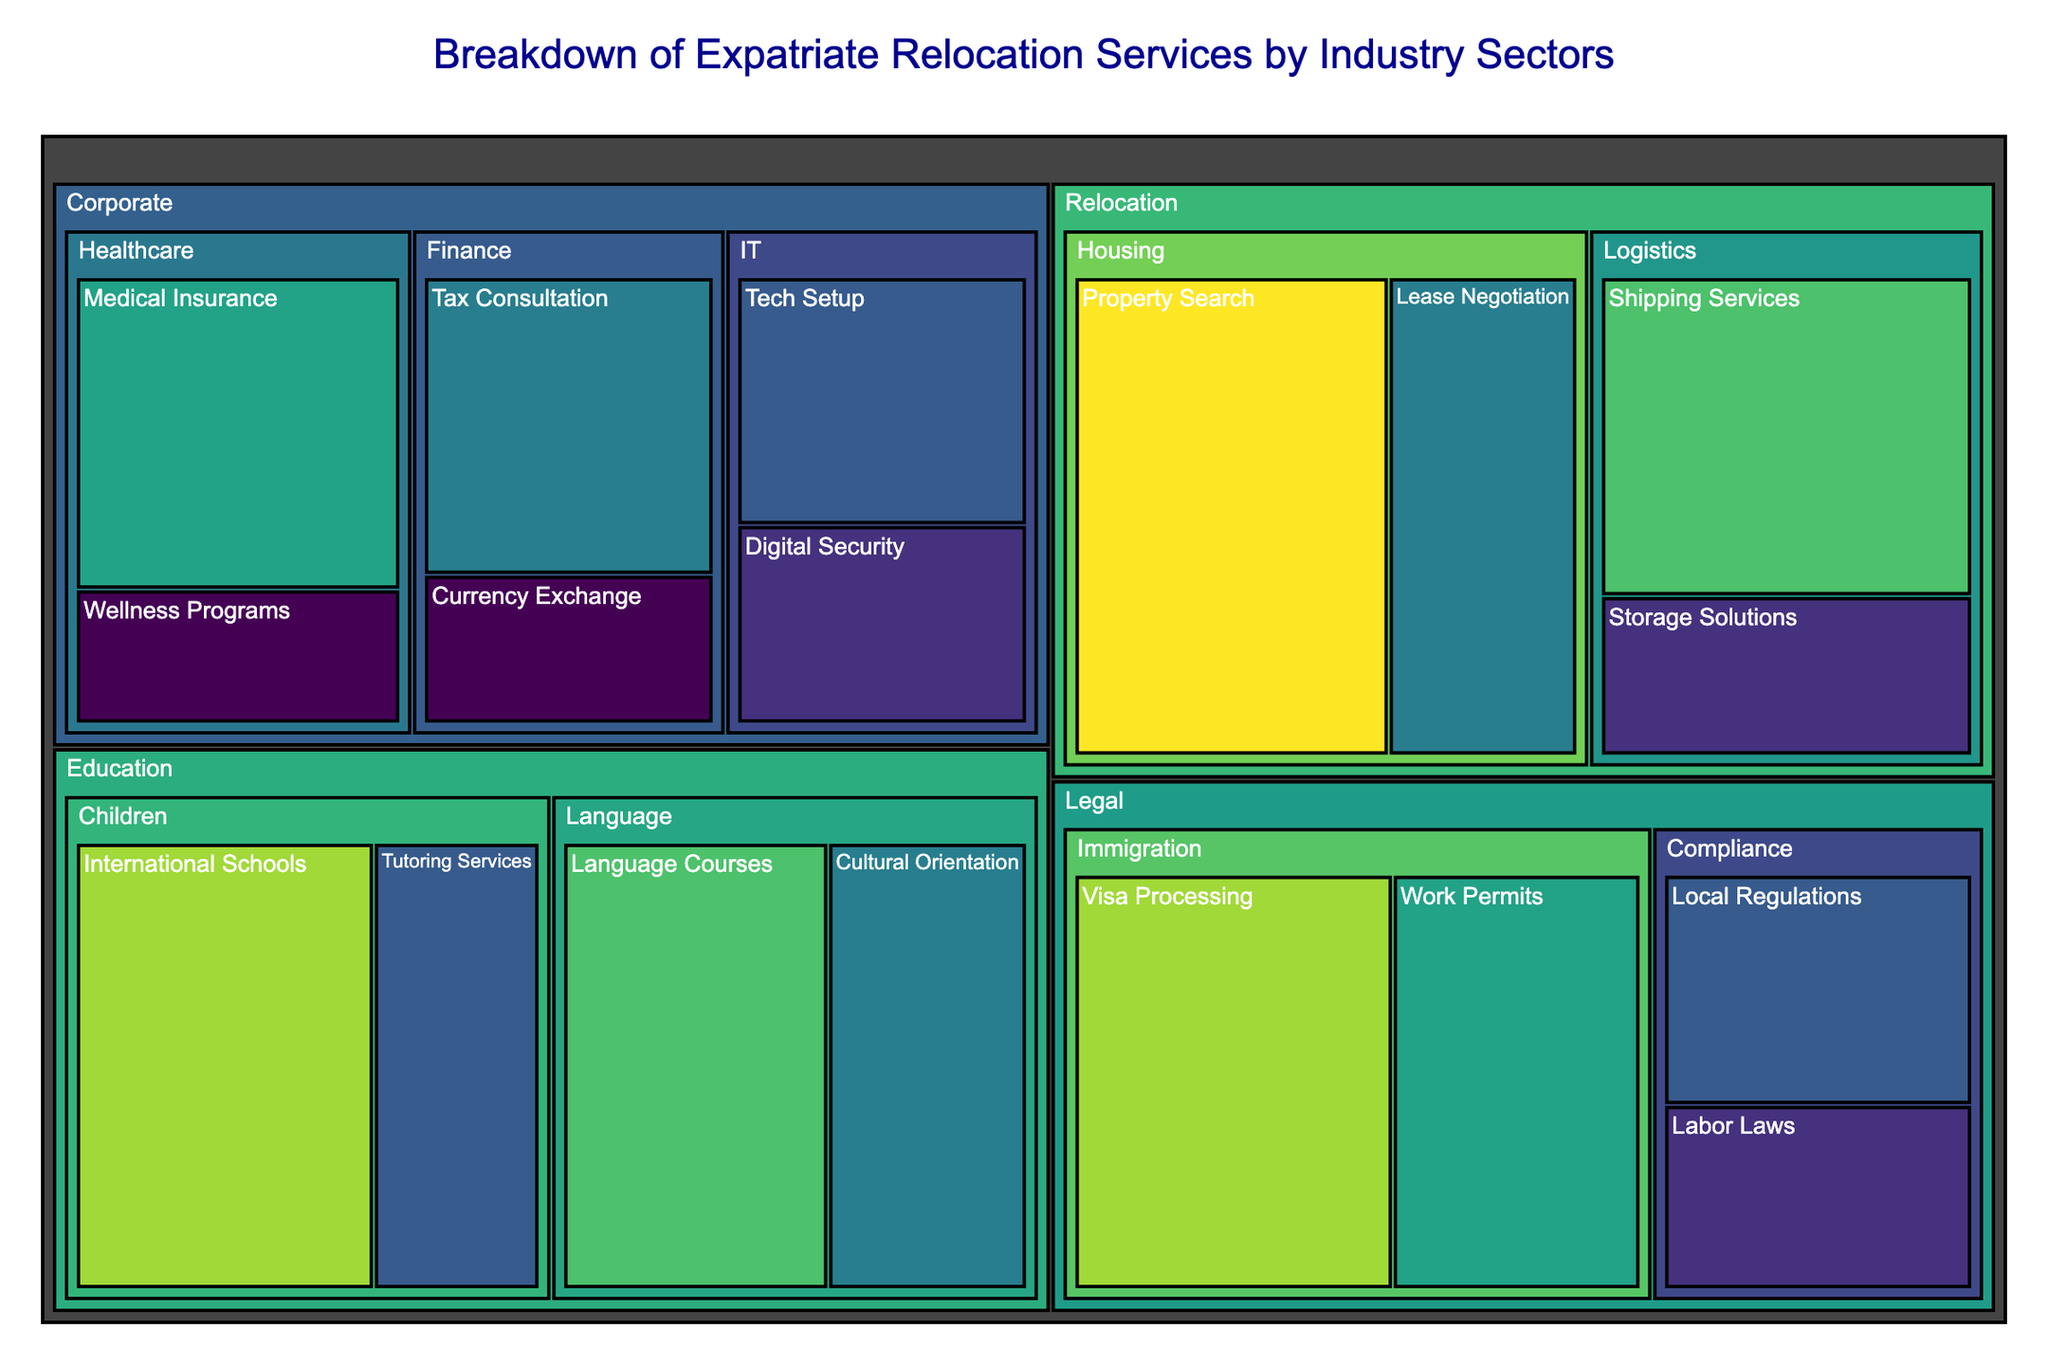Which industry sector has the highest value in its services? By looking at the treemap, identify the blocks with the largest areas because the area corresponds to the value of the services provided. The sector with the largest block will have the highest total value. In this case, it is the **Housing** sector under **Relocation** with values of 50 and 30, making a total of 80.
Answer: Housing What is the total value of services in the Corporate IT sector? Locate the IT sector under the Corporate industry in the treemap. Sum the values of all services within this sector, which are 25 and 20. Therefore, the total is 25 + 20.
Answer: 45 What service has the largest value in the Legal industry? Within the Legal industry on the treemap, identify the service with the largest block (area). This represents the service with the highest value. In this case, it is the Visa Processing service with a value of 45.
Answer: Visa Processing Compare the values of Property Search and Language Courses services. Which one is larger? Locate both Property Search under Relocation Housing and Language Courses under Education Language in the treemap. Compare their values. Property Search has a value of 50, and Language Courses has a value of 40. Hence, Property Search is larger.
Answer: Property Search What's the total value of services in the Education industry? Find all services under the Education industry on the treemap and sum their values. The services and values are Language Courses (40), Cultural Orientation (30), International Schools (45), and Tutoring Services (25). So, the total value is 40 + 30 + 45 + 25.
Answer: 140 Which industry has the most diverse services? Diversity here means the most number of distinct services within an industry. Visual inspection of the treemap shows the number of unique blocks (services) in each industry. Both the Corporate and Legal industries have 4 distinct services each.
Answer: Corporate and Legal What is the smallest value for any service within the Finance sector of the Corporate industry? Look at the services under the Finance sector of the Corporate industry in the treemap to find the smallest value. The services are Tax Consultation (30) and Currency Exchange (15). The smallest value is for Currency Exchange.
Answer: Currency Exchange Sum the values of the Medical Insurance and Wellness Programs services in the Healthcare sector. Look in the Corporate Healthcare sector of the treemap, identify the values of Medical Insurance (35) and Wellness Programs (15), and sum these values.
Answer: 50 Which has more value: Storage Solutions or Work Permits? Locate Storage Solutions under Relocation Logistics and Work Permits under Legal Immigration on the treemap. Compare their values. Storage Solutions has a value of 20, and Work Permits has a value of 35. Hence, Work Permits has more value.
Answer: Work Permits 